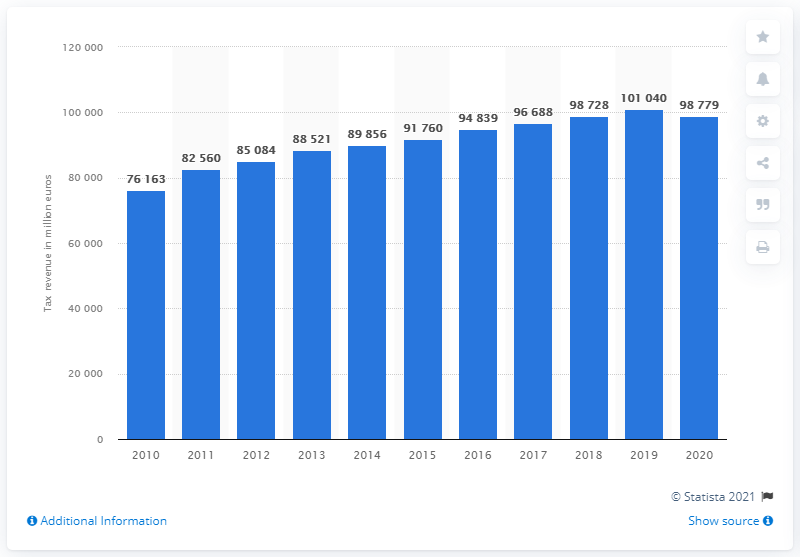Specify some key components in this picture. Finland's tax revenue in 2020 was approximately 98,779. 